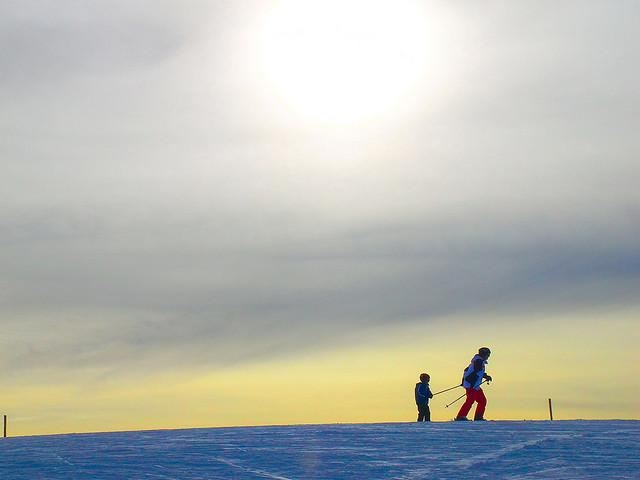What is the father doing with the child out on the mountain? skiing 